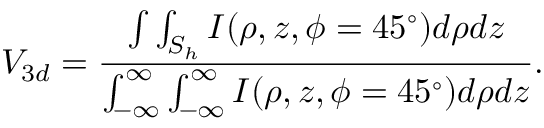Convert formula to latex. <formula><loc_0><loc_0><loc_500><loc_500>V _ { 3 d } = \frac { \int \int _ { S _ { h } } I ( \rho , z , \phi = 4 5 ^ { \circ } ) d \rho d z } { \int _ { - \infty } ^ { \infty } \int _ { - \infty } ^ { \infty } I ( \rho , z , \phi = 4 5 ^ { \circ } ) d \rho d z } .</formula> 